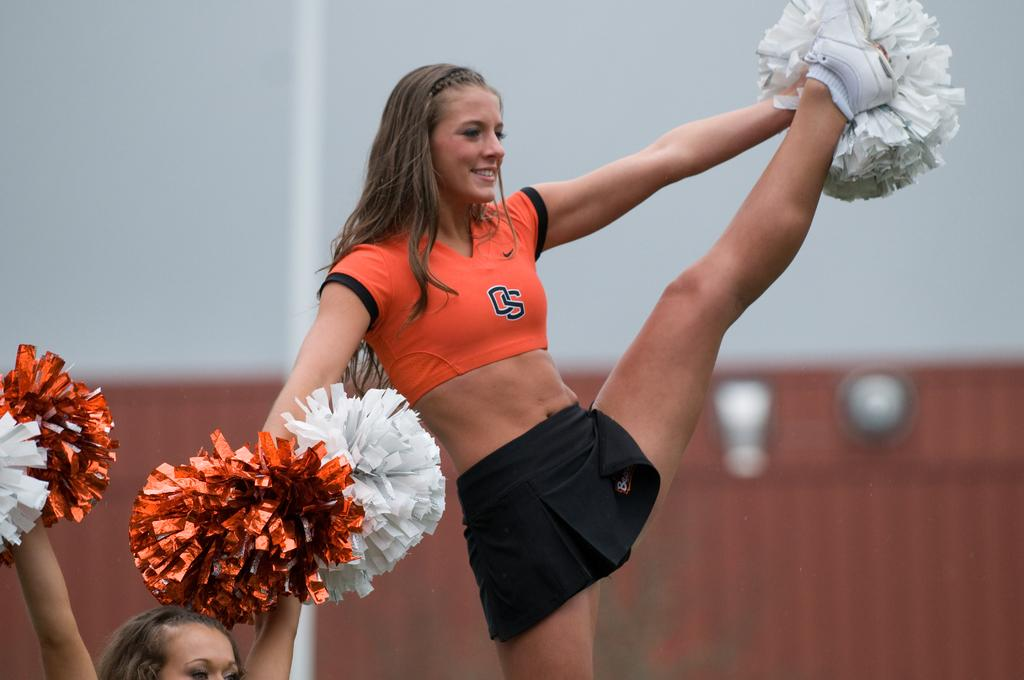<image>
Describe the image concisely. A cheerleader wearing black shorts and an orange top with the letters OS , holds pom poms ans kicks her leg high. 